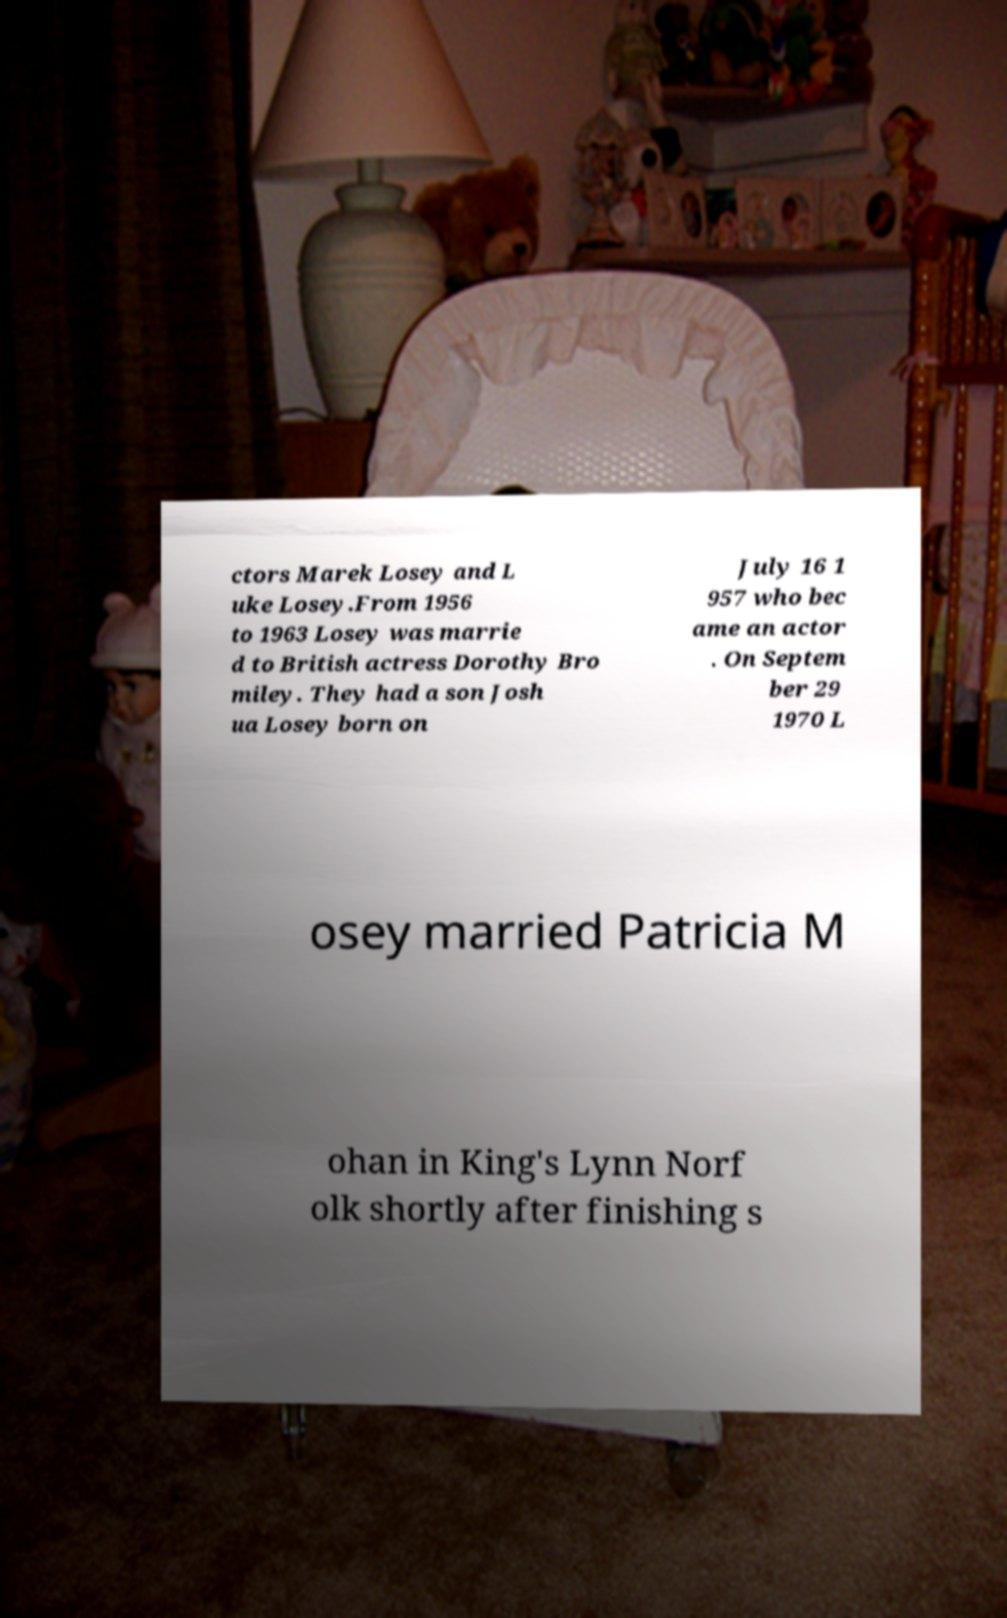I need the written content from this picture converted into text. Can you do that? ctors Marek Losey and L uke Losey.From 1956 to 1963 Losey was marrie d to British actress Dorothy Bro miley. They had a son Josh ua Losey born on July 16 1 957 who bec ame an actor . On Septem ber 29 1970 L osey married Patricia M ohan in King's Lynn Norf olk shortly after finishing s 